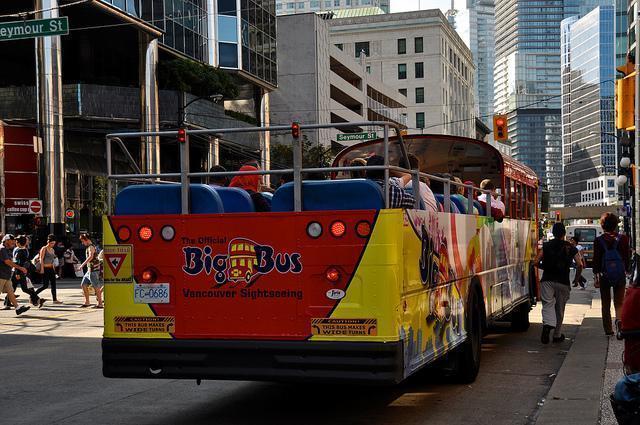What type of company owns the roofless bus?
Choose the right answer and clarify with the format: 'Answer: answer
Rationale: rationale.'
Options: Travel, city bus, tourist, sightseeing. Answer: sightseeing.
Rationale: A sightseeing company owns this roofless bus. 